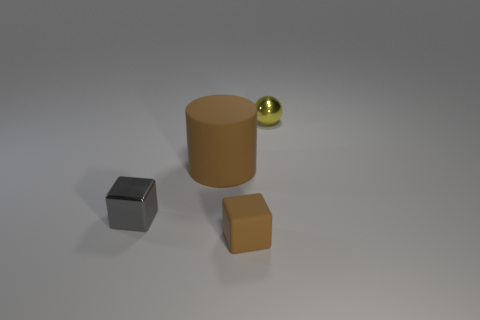There is a tiny rubber cube; is its color the same as the metallic thing in front of the large brown cylinder?
Provide a succinct answer. No. Is there another tiny metallic thing of the same shape as the small gray metal object?
Your answer should be compact. No. How many things are either yellow shiny spheres or brown rubber things in front of the gray block?
Offer a very short reply. 2. What number of other objects are the same material as the yellow sphere?
Your response must be concise. 1. How many objects are small gray things or spheres?
Ensure brevity in your answer.  2. Is the number of cylinders to the right of the brown cube greater than the number of tiny rubber objects that are left of the gray object?
Your answer should be compact. No. Do the cylinder that is behind the small gray cube and the small shiny object right of the gray metallic cube have the same color?
Your answer should be very brief. No. There is a object that is in front of the small metallic object on the left side of the metal object that is behind the tiny gray metal object; how big is it?
Keep it short and to the point. Small. There is another tiny object that is the same shape as the small rubber thing; what color is it?
Make the answer very short. Gray. Is the number of big cylinders in front of the small gray shiny object greater than the number of small brown rubber things?
Provide a short and direct response. No. 